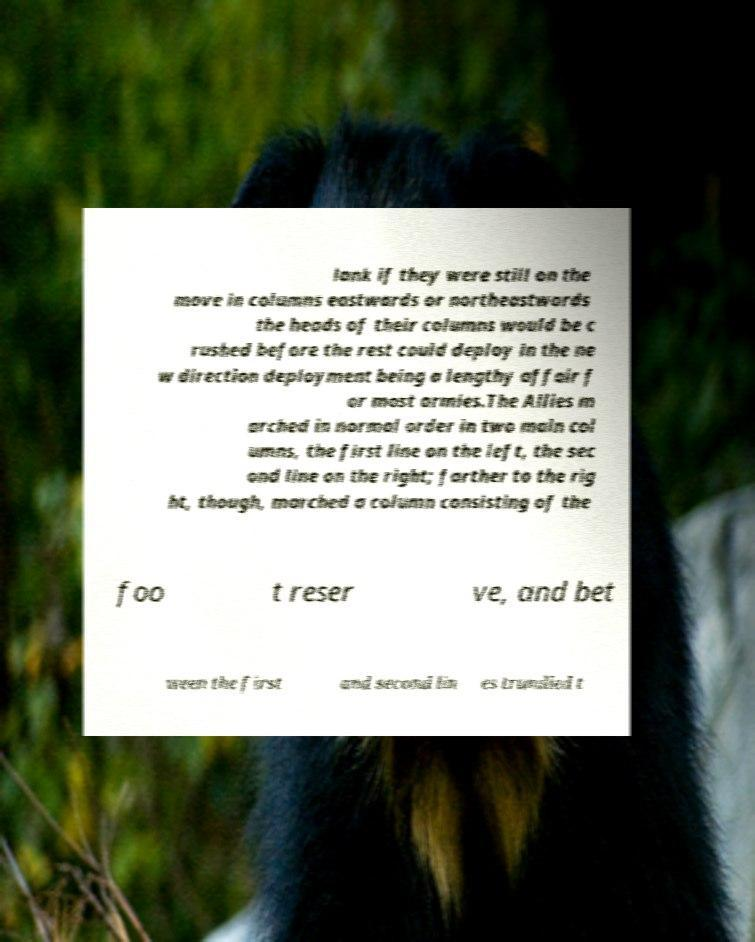There's text embedded in this image that I need extracted. Can you transcribe it verbatim? lank if they were still on the move in columns eastwards or northeastwards the heads of their columns would be c rushed before the rest could deploy in the ne w direction deployment being a lengthy affair f or most armies.The Allies m arched in normal order in two main col umns, the first line on the left, the sec ond line on the right; farther to the rig ht, though, marched a column consisting of the foo t reser ve, and bet ween the first and second lin es trundled t 